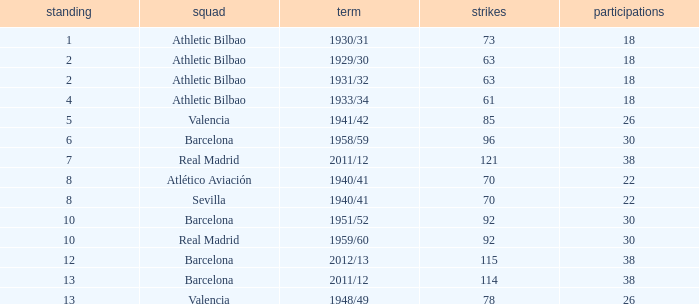What season was Barcelona ranked higher than 12, had more than 96 goals and had more than 26 apps? 2011/12. 